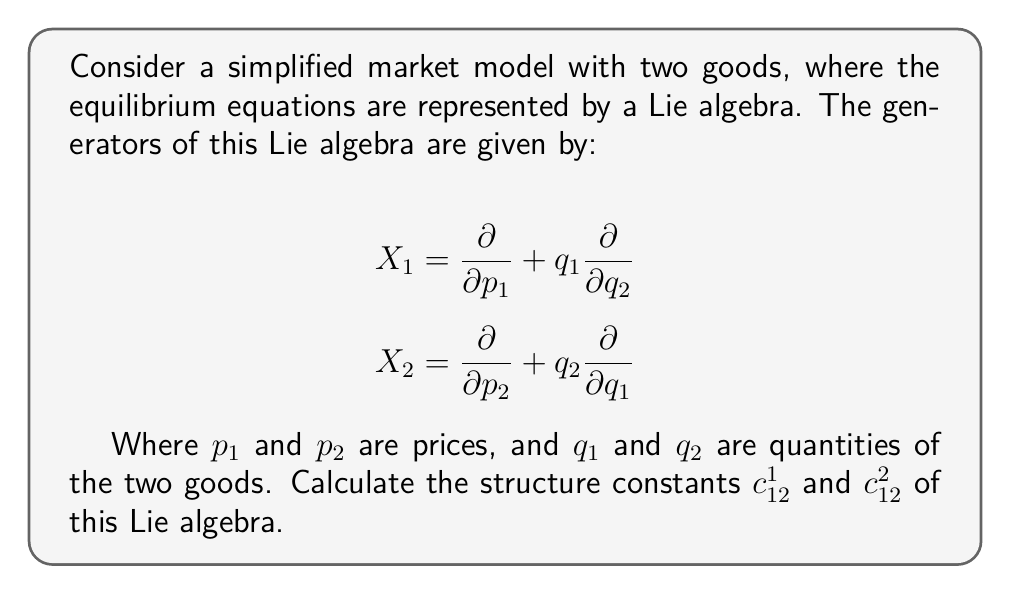What is the answer to this math problem? To calculate the structure constants of this Lie algebra, we need to follow these steps:

1) The structure constants are defined by the commutator of the generators:

   $$[X_i, X_j] = c_{ij}^k X_k$$

2) We need to calculate $[X_1, X_2]$:

   $$[X_1, X_2] = X_1X_2 - X_2X_1$$

3) Let's calculate $X_1X_2$:

   $$X_1X_2 = X_1(\frac{\partial}{\partial p_2} + q_2\frac{\partial}{\partial q_1})
   = \frac{\partial}{\partial p_2}(q_1\frac{\partial}{\partial q_2}) 
   = q_1\frac{\partial^2}{\partial p_2 \partial q_2}$$

4) Now, let's calculate $X_2X_1$:

   $$X_2X_1 = X_2(\frac{\partial}{\partial p_1} + q_1\frac{\partial}{\partial q_2})
   = \frac{\partial}{\partial p_1}(q_2\frac{\partial}{\partial q_1}) 
   = q_2\frac{\partial^2}{\partial p_1 \partial q_1}$$

5) Therefore, the commutator is:

   $$[X_1, X_2] = q_1\frac{\partial^2}{\partial p_2 \partial q_2} - q_2\frac{\partial^2}{\partial p_1 \partial q_1}$$

6) This result can be rewritten in terms of the original generators:

   $$[X_1, X_2] = -X_2 + X_1 = c_{12}^1 X_1 + c_{12}^2 X_2$$

7) By comparing coefficients, we can identify the structure constants:

   $$c_{12}^1 = 1$$
   $$c_{12}^2 = -1$$

These structure constants provide insights into the market dynamics and can be used in regulatory analysis and strategic planning.
Answer: The structure constants are:
$$c_{12}^1 = 1$$
$$c_{12}^2 = -1$$ 